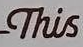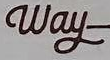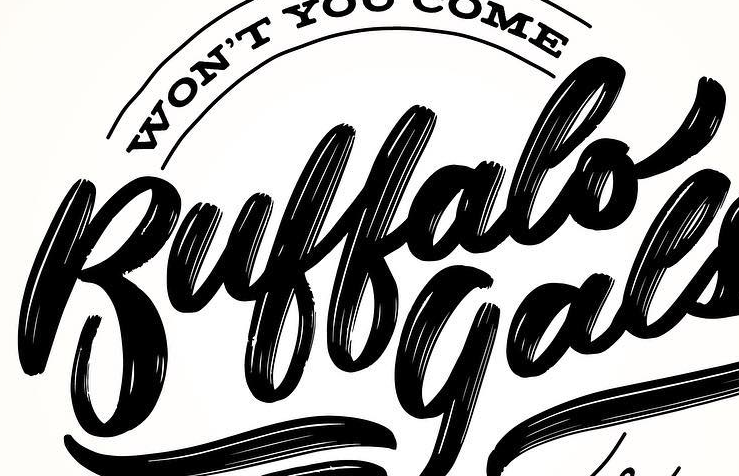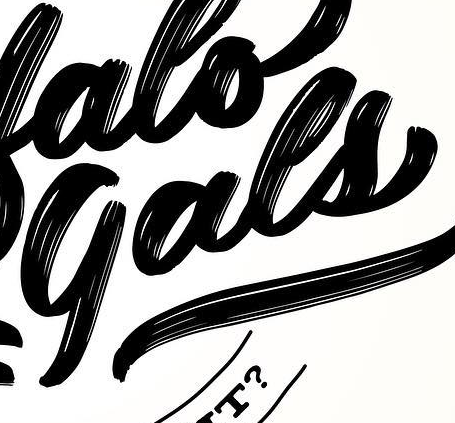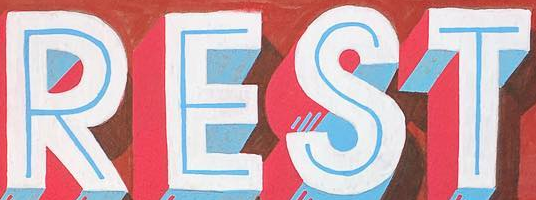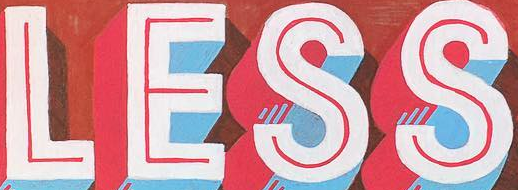Identify the words shown in these images in order, separated by a semicolon. This; Way; Buffalo; gals; REST; LESS 